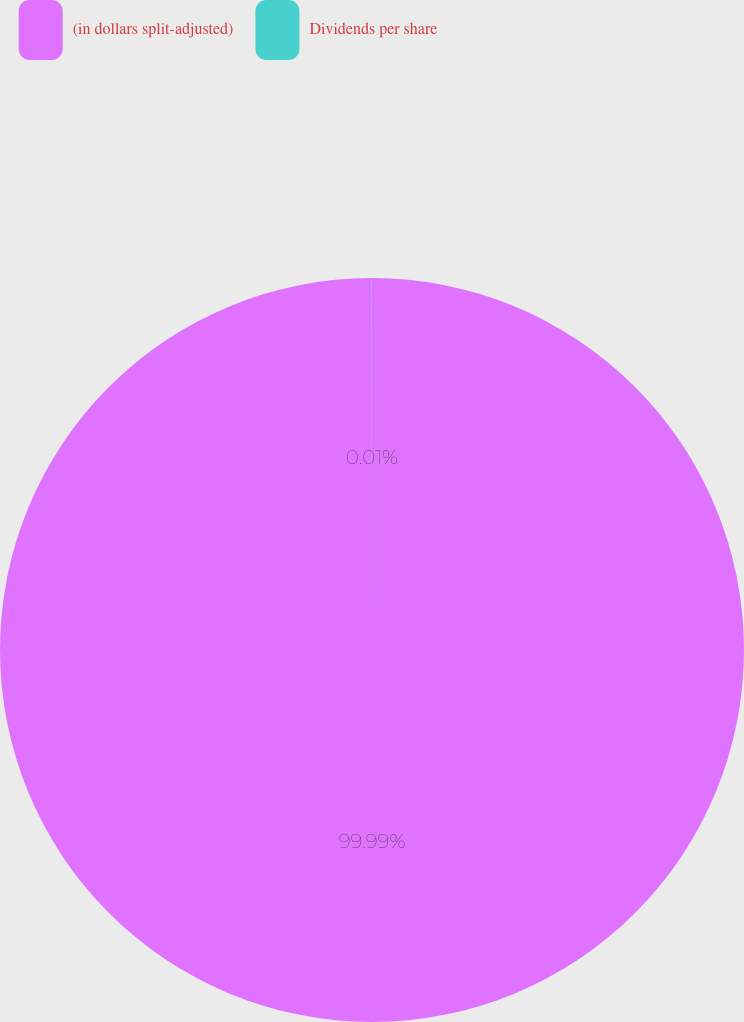Convert chart. <chart><loc_0><loc_0><loc_500><loc_500><pie_chart><fcel>(in dollars split-adjusted)<fcel>Dividends per share<nl><fcel>99.99%<fcel>0.01%<nl></chart> 